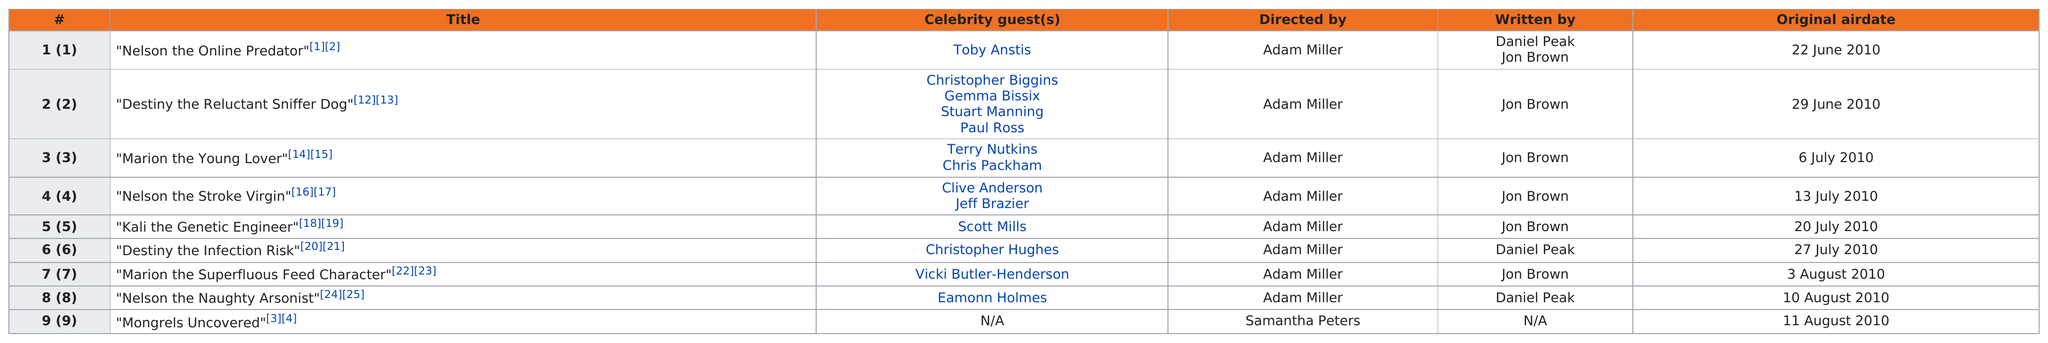Highlight a few significant elements in this photo. In episode 2, 4 guests appeared. In series 1 of 'Mongrels', two episodes were directed by Adam Miller but not written by Jon Brown. In July 2010, a total of 4 episodes were aired. Eamonn Holmes was the last celebrity guest in the 2010 season. Of the nine episodes in series 1 of Mongrels, the one with the most celebrity guests was episode 2. 